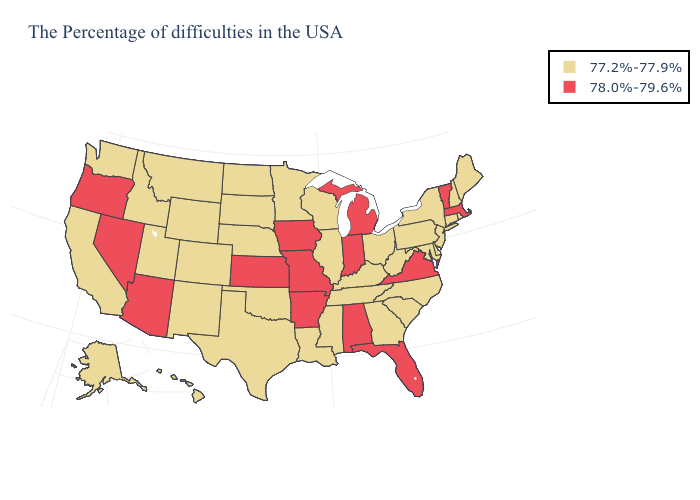Does Florida have the highest value in the USA?
Be succinct. Yes. Name the states that have a value in the range 77.2%-77.9%?
Answer briefly. Maine, Rhode Island, New Hampshire, Connecticut, New York, New Jersey, Delaware, Maryland, Pennsylvania, North Carolina, South Carolina, West Virginia, Ohio, Georgia, Kentucky, Tennessee, Wisconsin, Illinois, Mississippi, Louisiana, Minnesota, Nebraska, Oklahoma, Texas, South Dakota, North Dakota, Wyoming, Colorado, New Mexico, Utah, Montana, Idaho, California, Washington, Alaska, Hawaii. Does Washington have a higher value than Minnesota?
Answer briefly. No. What is the lowest value in the USA?
Keep it brief. 77.2%-77.9%. Name the states that have a value in the range 78.0%-79.6%?
Quick response, please. Massachusetts, Vermont, Virginia, Florida, Michigan, Indiana, Alabama, Missouri, Arkansas, Iowa, Kansas, Arizona, Nevada, Oregon. What is the value of Maine?
Keep it brief. 77.2%-77.9%. Name the states that have a value in the range 78.0%-79.6%?
Give a very brief answer. Massachusetts, Vermont, Virginia, Florida, Michigan, Indiana, Alabama, Missouri, Arkansas, Iowa, Kansas, Arizona, Nevada, Oregon. How many symbols are there in the legend?
Keep it brief. 2. Which states hav the highest value in the MidWest?
Answer briefly. Michigan, Indiana, Missouri, Iowa, Kansas. What is the value of Maryland?
Write a very short answer. 77.2%-77.9%. Name the states that have a value in the range 77.2%-77.9%?
Concise answer only. Maine, Rhode Island, New Hampshire, Connecticut, New York, New Jersey, Delaware, Maryland, Pennsylvania, North Carolina, South Carolina, West Virginia, Ohio, Georgia, Kentucky, Tennessee, Wisconsin, Illinois, Mississippi, Louisiana, Minnesota, Nebraska, Oklahoma, Texas, South Dakota, North Dakota, Wyoming, Colorado, New Mexico, Utah, Montana, Idaho, California, Washington, Alaska, Hawaii. Does Oregon have the highest value in the West?
Answer briefly. Yes. Which states have the lowest value in the USA?
Short answer required. Maine, Rhode Island, New Hampshire, Connecticut, New York, New Jersey, Delaware, Maryland, Pennsylvania, North Carolina, South Carolina, West Virginia, Ohio, Georgia, Kentucky, Tennessee, Wisconsin, Illinois, Mississippi, Louisiana, Minnesota, Nebraska, Oklahoma, Texas, South Dakota, North Dakota, Wyoming, Colorado, New Mexico, Utah, Montana, Idaho, California, Washington, Alaska, Hawaii. Which states have the lowest value in the USA?
Quick response, please. Maine, Rhode Island, New Hampshire, Connecticut, New York, New Jersey, Delaware, Maryland, Pennsylvania, North Carolina, South Carolina, West Virginia, Ohio, Georgia, Kentucky, Tennessee, Wisconsin, Illinois, Mississippi, Louisiana, Minnesota, Nebraska, Oklahoma, Texas, South Dakota, North Dakota, Wyoming, Colorado, New Mexico, Utah, Montana, Idaho, California, Washington, Alaska, Hawaii. 